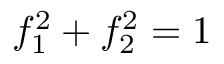Convert formula to latex. <formula><loc_0><loc_0><loc_500><loc_500>f _ { 1 } ^ { 2 } + f _ { 2 } ^ { 2 } = 1</formula> 